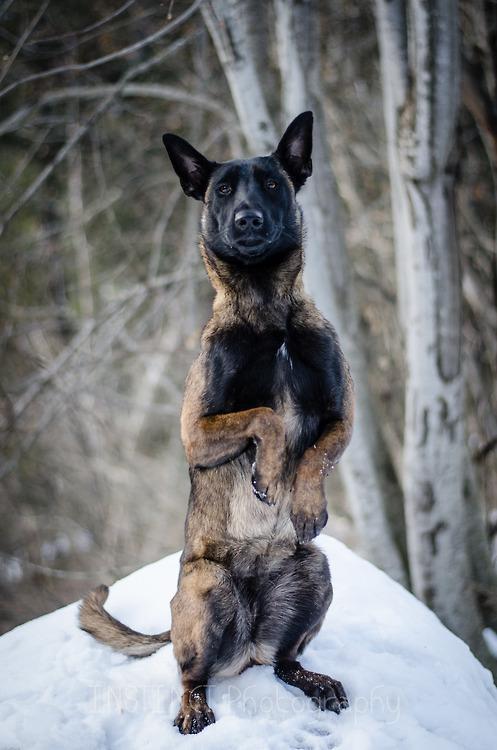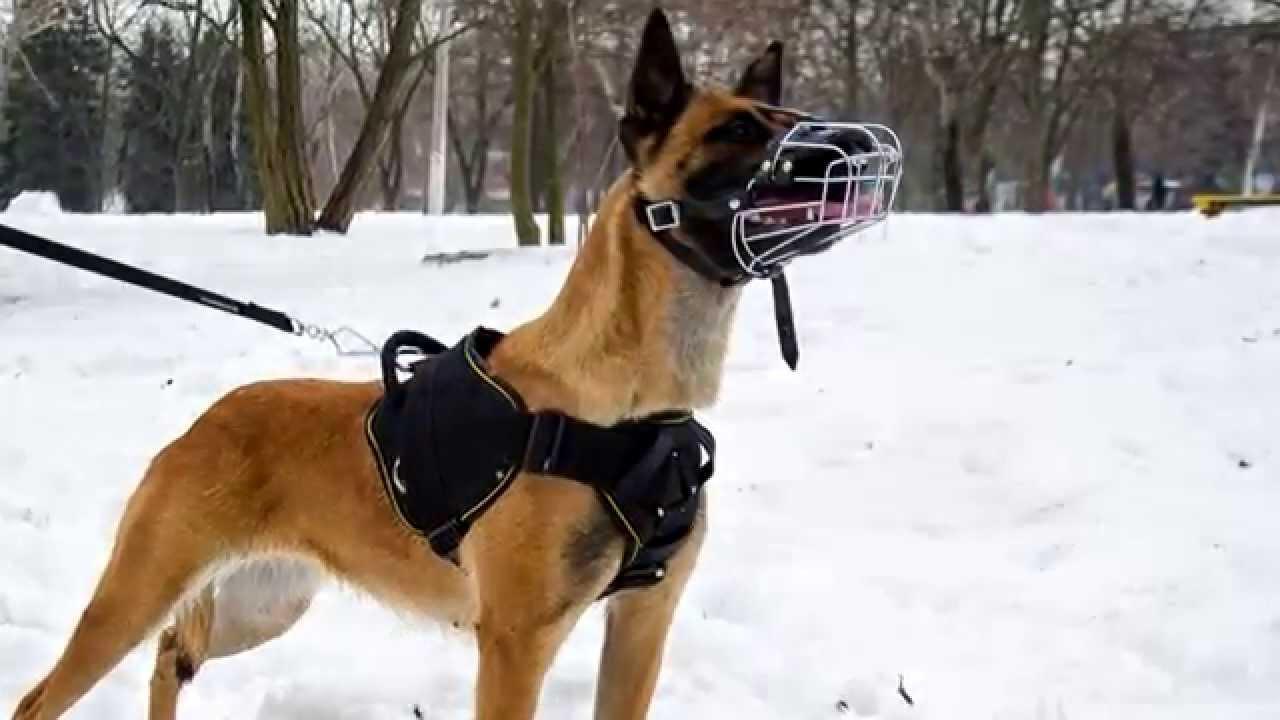The first image is the image on the left, the second image is the image on the right. Examine the images to the left and right. Is the description "The dog in the image on the left is baring its teeth." accurate? Answer yes or no. No. The first image is the image on the left, the second image is the image on the right. Considering the images on both sides, is "An image shows one german shepherd dog with a dusting of snow on the fur of its face." valid? Answer yes or no. No. 